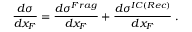Convert formula to latex. <formula><loc_0><loc_0><loc_500><loc_500>\frac { d \sigma } { d x _ { F } } = \frac { d \sigma ^ { F r a g } } { d x _ { F } } + \frac { d \sigma ^ { I C ( R e c ) } } { d x _ { F } } \, .</formula> 